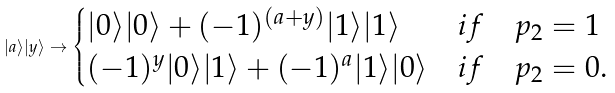Convert formula to latex. <formula><loc_0><loc_0><loc_500><loc_500>| a \rangle | y \rangle \rightarrow \begin{cases} | 0 \rangle | 0 \rangle + ( - 1 ) ^ { ( a + y ) } | 1 \rangle | 1 \rangle & i f \quad p _ { 2 } = 1 \\ ( - 1 ) ^ { y } | 0 \rangle | 1 \rangle + ( - 1 ) ^ { a } | 1 \rangle | 0 \rangle & i f \quad p _ { 2 } = 0 . \end{cases}</formula> 